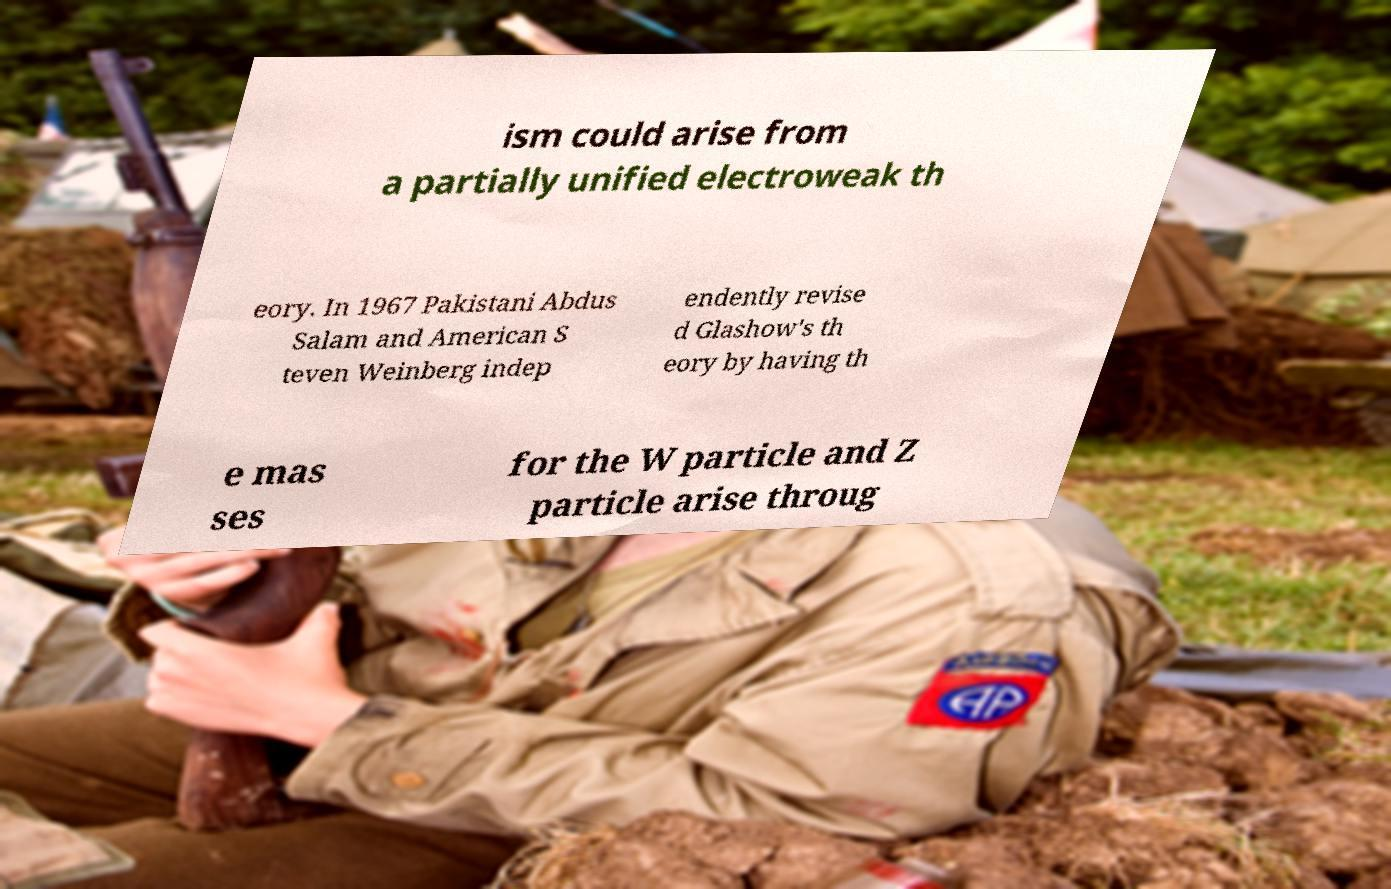Can you accurately transcribe the text from the provided image for me? ism could arise from a partially unified electroweak th eory. In 1967 Pakistani Abdus Salam and American S teven Weinberg indep endently revise d Glashow's th eory by having th e mas ses for the W particle and Z particle arise throug 